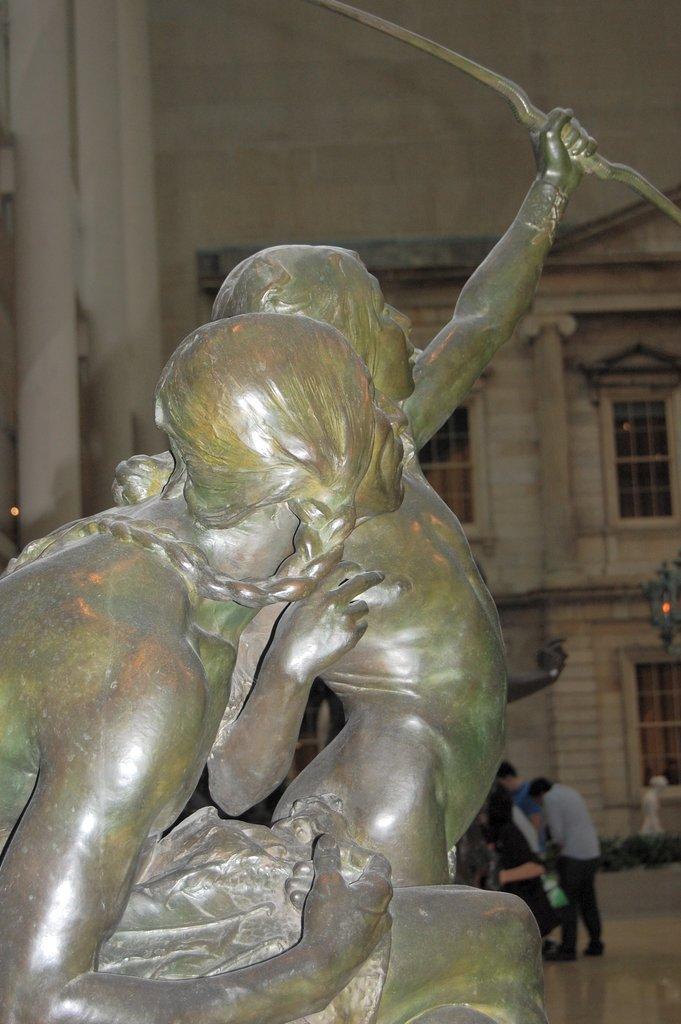Could you give a brief overview of what you see in this image? In this image there is a statue of two people holding an object, behind the statue there are a few people standing on the floor. In the background there is a building. 